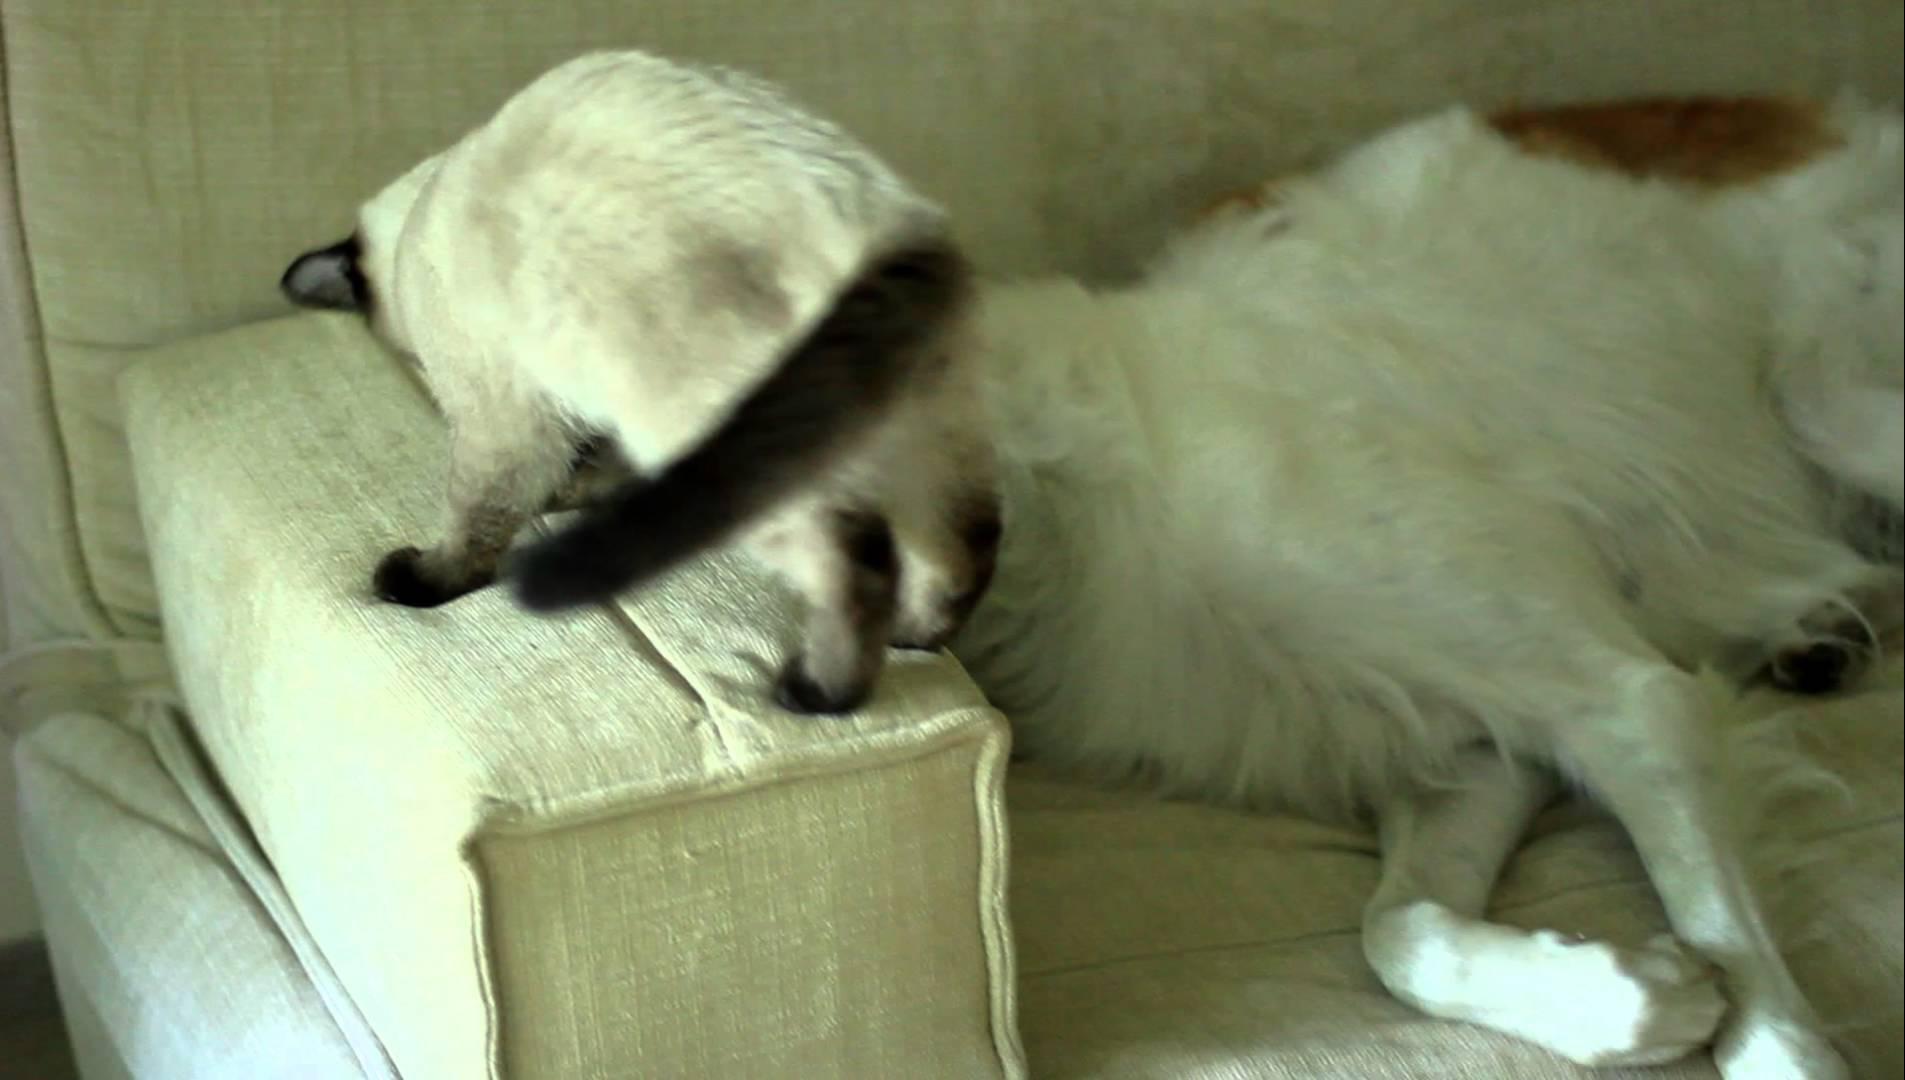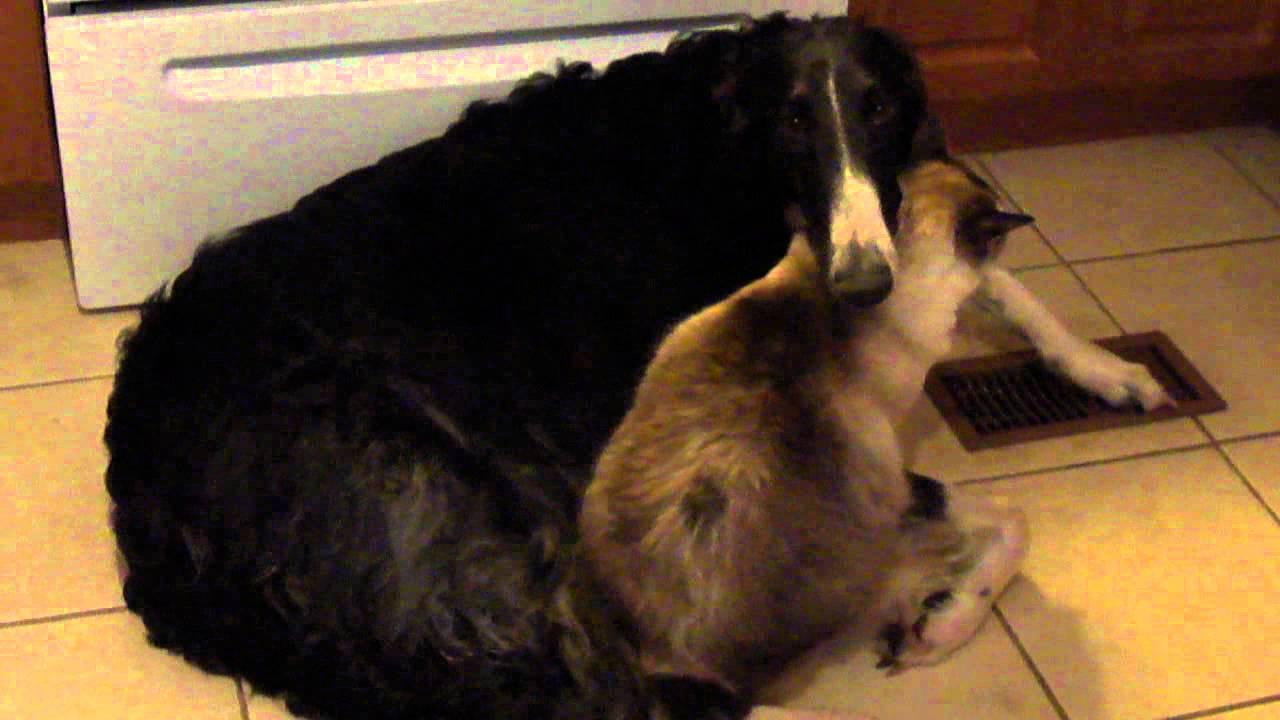The first image is the image on the left, the second image is the image on the right. For the images shown, is this caption "There is exactly one sleeping dog wearing a collar." true? Answer yes or no. No. 